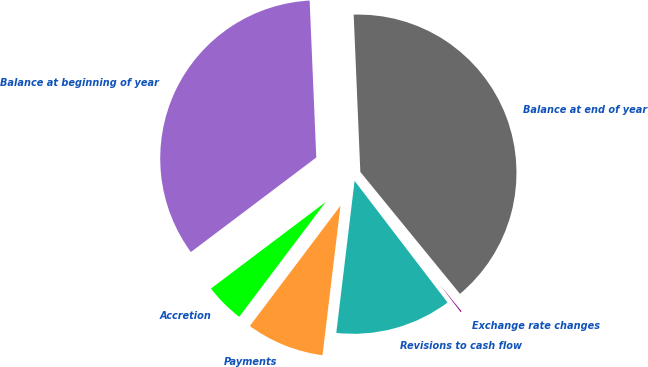Convert chart to OTSL. <chart><loc_0><loc_0><loc_500><loc_500><pie_chart><fcel>Balance at beginning of year<fcel>Accretion<fcel>Payments<fcel>Revisions to cash flow<fcel>Exchange rate changes<fcel>Balance at end of year<nl><fcel>34.61%<fcel>4.44%<fcel>8.37%<fcel>12.29%<fcel>0.52%<fcel>39.77%<nl></chart> 